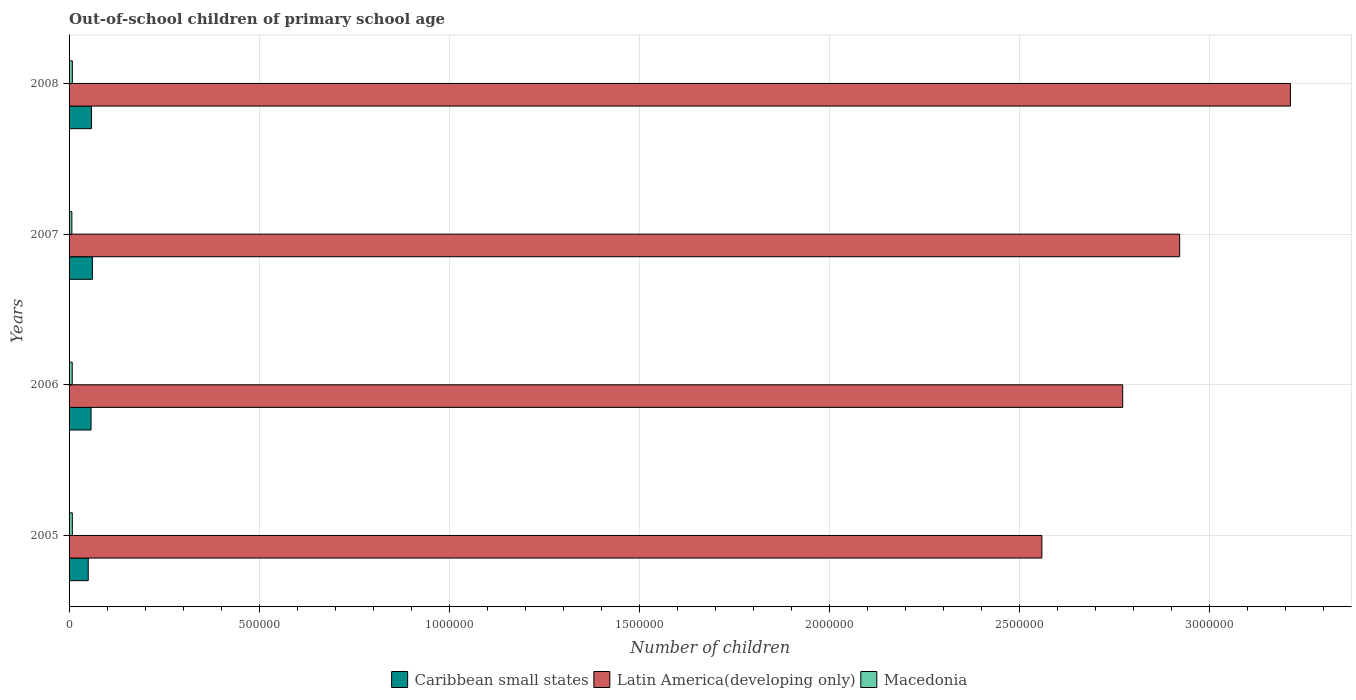How many groups of bars are there?
Your answer should be very brief. 4. What is the number of out-of-school children in Caribbean small states in 2006?
Your answer should be compact. 5.78e+04. Across all years, what is the maximum number of out-of-school children in Macedonia?
Offer a very short reply. 8560. Across all years, what is the minimum number of out-of-school children in Caribbean small states?
Your answer should be very brief. 5.04e+04. In which year was the number of out-of-school children in Macedonia maximum?
Your response must be concise. 2008. In which year was the number of out-of-school children in Latin America(developing only) minimum?
Offer a very short reply. 2005. What is the total number of out-of-school children in Latin America(developing only) in the graph?
Make the answer very short. 1.15e+07. What is the difference between the number of out-of-school children in Latin America(developing only) in 2006 and that in 2008?
Your response must be concise. -4.41e+05. What is the difference between the number of out-of-school children in Latin America(developing only) in 2008 and the number of out-of-school children in Caribbean small states in 2007?
Make the answer very short. 3.15e+06. What is the average number of out-of-school children in Macedonia per year?
Offer a very short reply. 8189.5. In the year 2008, what is the difference between the number of out-of-school children in Macedonia and number of out-of-school children in Caribbean small states?
Your response must be concise. -5.04e+04. In how many years, is the number of out-of-school children in Latin America(developing only) greater than 1600000 ?
Your response must be concise. 4. What is the ratio of the number of out-of-school children in Macedonia in 2007 to that in 2008?
Your answer should be compact. 0.86. Is the difference between the number of out-of-school children in Macedonia in 2007 and 2008 greater than the difference between the number of out-of-school children in Caribbean small states in 2007 and 2008?
Offer a very short reply. No. What is the difference between the highest and the lowest number of out-of-school children in Caribbean small states?
Keep it short and to the point. 1.09e+04. In how many years, is the number of out-of-school children in Latin America(developing only) greater than the average number of out-of-school children in Latin America(developing only) taken over all years?
Provide a short and direct response. 2. What does the 3rd bar from the top in 2005 represents?
Offer a very short reply. Caribbean small states. What does the 3rd bar from the bottom in 2005 represents?
Provide a short and direct response. Macedonia. Is it the case that in every year, the sum of the number of out-of-school children in Macedonia and number of out-of-school children in Latin America(developing only) is greater than the number of out-of-school children in Caribbean small states?
Make the answer very short. Yes. How many bars are there?
Ensure brevity in your answer.  12. Are all the bars in the graph horizontal?
Provide a short and direct response. Yes. How many years are there in the graph?
Provide a short and direct response. 4. Are the values on the major ticks of X-axis written in scientific E-notation?
Offer a terse response. No. Does the graph contain any zero values?
Give a very brief answer. No. Does the graph contain grids?
Keep it short and to the point. Yes. How many legend labels are there?
Your answer should be compact. 3. What is the title of the graph?
Your answer should be very brief. Out-of-school children of primary school age. Does "Comoros" appear as one of the legend labels in the graph?
Offer a very short reply. No. What is the label or title of the X-axis?
Provide a short and direct response. Number of children. What is the label or title of the Y-axis?
Give a very brief answer. Years. What is the Number of children in Caribbean small states in 2005?
Keep it short and to the point. 5.04e+04. What is the Number of children in Latin America(developing only) in 2005?
Your answer should be very brief. 2.56e+06. What is the Number of children in Macedonia in 2005?
Offer a terse response. 8556. What is the Number of children in Caribbean small states in 2006?
Ensure brevity in your answer.  5.78e+04. What is the Number of children in Latin America(developing only) in 2006?
Offer a terse response. 2.77e+06. What is the Number of children in Macedonia in 2006?
Make the answer very short. 8298. What is the Number of children of Caribbean small states in 2007?
Your answer should be compact. 6.13e+04. What is the Number of children of Latin America(developing only) in 2007?
Your answer should be very brief. 2.92e+06. What is the Number of children of Macedonia in 2007?
Your response must be concise. 7344. What is the Number of children of Caribbean small states in 2008?
Ensure brevity in your answer.  5.90e+04. What is the Number of children in Latin America(developing only) in 2008?
Provide a succinct answer. 3.21e+06. What is the Number of children of Macedonia in 2008?
Keep it short and to the point. 8560. Across all years, what is the maximum Number of children in Caribbean small states?
Make the answer very short. 6.13e+04. Across all years, what is the maximum Number of children in Latin America(developing only)?
Give a very brief answer. 3.21e+06. Across all years, what is the maximum Number of children in Macedonia?
Offer a terse response. 8560. Across all years, what is the minimum Number of children in Caribbean small states?
Make the answer very short. 5.04e+04. Across all years, what is the minimum Number of children of Latin America(developing only)?
Your answer should be compact. 2.56e+06. Across all years, what is the minimum Number of children in Macedonia?
Make the answer very short. 7344. What is the total Number of children in Caribbean small states in the graph?
Your answer should be compact. 2.29e+05. What is the total Number of children of Latin America(developing only) in the graph?
Provide a short and direct response. 1.15e+07. What is the total Number of children in Macedonia in the graph?
Make the answer very short. 3.28e+04. What is the difference between the Number of children in Caribbean small states in 2005 and that in 2006?
Offer a terse response. -7393. What is the difference between the Number of children in Latin America(developing only) in 2005 and that in 2006?
Provide a succinct answer. -2.13e+05. What is the difference between the Number of children in Macedonia in 2005 and that in 2006?
Provide a succinct answer. 258. What is the difference between the Number of children in Caribbean small states in 2005 and that in 2007?
Provide a succinct answer. -1.09e+04. What is the difference between the Number of children in Latin America(developing only) in 2005 and that in 2007?
Offer a very short reply. -3.62e+05. What is the difference between the Number of children of Macedonia in 2005 and that in 2007?
Make the answer very short. 1212. What is the difference between the Number of children in Caribbean small states in 2005 and that in 2008?
Provide a short and direct response. -8537. What is the difference between the Number of children of Latin America(developing only) in 2005 and that in 2008?
Offer a very short reply. -6.54e+05. What is the difference between the Number of children of Caribbean small states in 2006 and that in 2007?
Your answer should be very brief. -3523. What is the difference between the Number of children in Latin America(developing only) in 2006 and that in 2007?
Your answer should be very brief. -1.50e+05. What is the difference between the Number of children in Macedonia in 2006 and that in 2007?
Ensure brevity in your answer.  954. What is the difference between the Number of children in Caribbean small states in 2006 and that in 2008?
Make the answer very short. -1144. What is the difference between the Number of children in Latin America(developing only) in 2006 and that in 2008?
Offer a terse response. -4.41e+05. What is the difference between the Number of children in Macedonia in 2006 and that in 2008?
Your response must be concise. -262. What is the difference between the Number of children in Caribbean small states in 2007 and that in 2008?
Provide a short and direct response. 2379. What is the difference between the Number of children of Latin America(developing only) in 2007 and that in 2008?
Provide a succinct answer. -2.91e+05. What is the difference between the Number of children in Macedonia in 2007 and that in 2008?
Your answer should be very brief. -1216. What is the difference between the Number of children of Caribbean small states in 2005 and the Number of children of Latin America(developing only) in 2006?
Your answer should be very brief. -2.72e+06. What is the difference between the Number of children of Caribbean small states in 2005 and the Number of children of Macedonia in 2006?
Offer a terse response. 4.21e+04. What is the difference between the Number of children of Latin America(developing only) in 2005 and the Number of children of Macedonia in 2006?
Your answer should be compact. 2.55e+06. What is the difference between the Number of children of Caribbean small states in 2005 and the Number of children of Latin America(developing only) in 2007?
Keep it short and to the point. -2.87e+06. What is the difference between the Number of children of Caribbean small states in 2005 and the Number of children of Macedonia in 2007?
Your answer should be compact. 4.31e+04. What is the difference between the Number of children in Latin America(developing only) in 2005 and the Number of children in Macedonia in 2007?
Ensure brevity in your answer.  2.55e+06. What is the difference between the Number of children of Caribbean small states in 2005 and the Number of children of Latin America(developing only) in 2008?
Your answer should be very brief. -3.16e+06. What is the difference between the Number of children of Caribbean small states in 2005 and the Number of children of Macedonia in 2008?
Make the answer very short. 4.19e+04. What is the difference between the Number of children in Latin America(developing only) in 2005 and the Number of children in Macedonia in 2008?
Offer a very short reply. 2.55e+06. What is the difference between the Number of children in Caribbean small states in 2006 and the Number of children in Latin America(developing only) in 2007?
Give a very brief answer. -2.86e+06. What is the difference between the Number of children in Caribbean small states in 2006 and the Number of children in Macedonia in 2007?
Provide a succinct answer. 5.05e+04. What is the difference between the Number of children in Latin America(developing only) in 2006 and the Number of children in Macedonia in 2007?
Offer a terse response. 2.76e+06. What is the difference between the Number of children of Caribbean small states in 2006 and the Number of children of Latin America(developing only) in 2008?
Keep it short and to the point. -3.16e+06. What is the difference between the Number of children in Caribbean small states in 2006 and the Number of children in Macedonia in 2008?
Offer a very short reply. 4.93e+04. What is the difference between the Number of children in Latin America(developing only) in 2006 and the Number of children in Macedonia in 2008?
Your answer should be compact. 2.76e+06. What is the difference between the Number of children of Caribbean small states in 2007 and the Number of children of Latin America(developing only) in 2008?
Offer a very short reply. -3.15e+06. What is the difference between the Number of children in Caribbean small states in 2007 and the Number of children in Macedonia in 2008?
Provide a short and direct response. 5.28e+04. What is the difference between the Number of children in Latin America(developing only) in 2007 and the Number of children in Macedonia in 2008?
Give a very brief answer. 2.91e+06. What is the average Number of children of Caribbean small states per year?
Give a very brief answer. 5.71e+04. What is the average Number of children in Latin America(developing only) per year?
Your answer should be very brief. 2.87e+06. What is the average Number of children in Macedonia per year?
Offer a very short reply. 8189.5. In the year 2005, what is the difference between the Number of children in Caribbean small states and Number of children in Latin America(developing only)?
Your answer should be compact. -2.51e+06. In the year 2005, what is the difference between the Number of children of Caribbean small states and Number of children of Macedonia?
Offer a terse response. 4.19e+04. In the year 2005, what is the difference between the Number of children of Latin America(developing only) and Number of children of Macedonia?
Offer a terse response. 2.55e+06. In the year 2006, what is the difference between the Number of children in Caribbean small states and Number of children in Latin America(developing only)?
Keep it short and to the point. -2.71e+06. In the year 2006, what is the difference between the Number of children in Caribbean small states and Number of children in Macedonia?
Provide a short and direct response. 4.95e+04. In the year 2006, what is the difference between the Number of children in Latin America(developing only) and Number of children in Macedonia?
Provide a short and direct response. 2.76e+06. In the year 2007, what is the difference between the Number of children of Caribbean small states and Number of children of Latin America(developing only)?
Make the answer very short. -2.86e+06. In the year 2007, what is the difference between the Number of children in Caribbean small states and Number of children in Macedonia?
Your answer should be compact. 5.40e+04. In the year 2007, what is the difference between the Number of children of Latin America(developing only) and Number of children of Macedonia?
Give a very brief answer. 2.91e+06. In the year 2008, what is the difference between the Number of children of Caribbean small states and Number of children of Latin America(developing only)?
Your answer should be compact. -3.15e+06. In the year 2008, what is the difference between the Number of children of Caribbean small states and Number of children of Macedonia?
Offer a terse response. 5.04e+04. In the year 2008, what is the difference between the Number of children in Latin America(developing only) and Number of children in Macedonia?
Offer a terse response. 3.20e+06. What is the ratio of the Number of children of Caribbean small states in 2005 to that in 2006?
Keep it short and to the point. 0.87. What is the ratio of the Number of children of Latin America(developing only) in 2005 to that in 2006?
Give a very brief answer. 0.92. What is the ratio of the Number of children in Macedonia in 2005 to that in 2006?
Offer a very short reply. 1.03. What is the ratio of the Number of children in Caribbean small states in 2005 to that in 2007?
Ensure brevity in your answer.  0.82. What is the ratio of the Number of children in Latin America(developing only) in 2005 to that in 2007?
Keep it short and to the point. 0.88. What is the ratio of the Number of children of Macedonia in 2005 to that in 2007?
Your answer should be compact. 1.17. What is the ratio of the Number of children of Caribbean small states in 2005 to that in 2008?
Offer a very short reply. 0.86. What is the ratio of the Number of children of Latin America(developing only) in 2005 to that in 2008?
Provide a succinct answer. 0.8. What is the ratio of the Number of children in Macedonia in 2005 to that in 2008?
Keep it short and to the point. 1. What is the ratio of the Number of children of Caribbean small states in 2006 to that in 2007?
Your answer should be compact. 0.94. What is the ratio of the Number of children of Latin America(developing only) in 2006 to that in 2007?
Your response must be concise. 0.95. What is the ratio of the Number of children of Macedonia in 2006 to that in 2007?
Keep it short and to the point. 1.13. What is the ratio of the Number of children of Caribbean small states in 2006 to that in 2008?
Offer a very short reply. 0.98. What is the ratio of the Number of children of Latin America(developing only) in 2006 to that in 2008?
Your answer should be very brief. 0.86. What is the ratio of the Number of children in Macedonia in 2006 to that in 2008?
Ensure brevity in your answer.  0.97. What is the ratio of the Number of children of Caribbean small states in 2007 to that in 2008?
Ensure brevity in your answer.  1.04. What is the ratio of the Number of children of Latin America(developing only) in 2007 to that in 2008?
Keep it short and to the point. 0.91. What is the ratio of the Number of children of Macedonia in 2007 to that in 2008?
Your response must be concise. 0.86. What is the difference between the highest and the second highest Number of children in Caribbean small states?
Offer a terse response. 2379. What is the difference between the highest and the second highest Number of children in Latin America(developing only)?
Provide a short and direct response. 2.91e+05. What is the difference between the highest and the lowest Number of children in Caribbean small states?
Ensure brevity in your answer.  1.09e+04. What is the difference between the highest and the lowest Number of children of Latin America(developing only)?
Your response must be concise. 6.54e+05. What is the difference between the highest and the lowest Number of children of Macedonia?
Ensure brevity in your answer.  1216. 